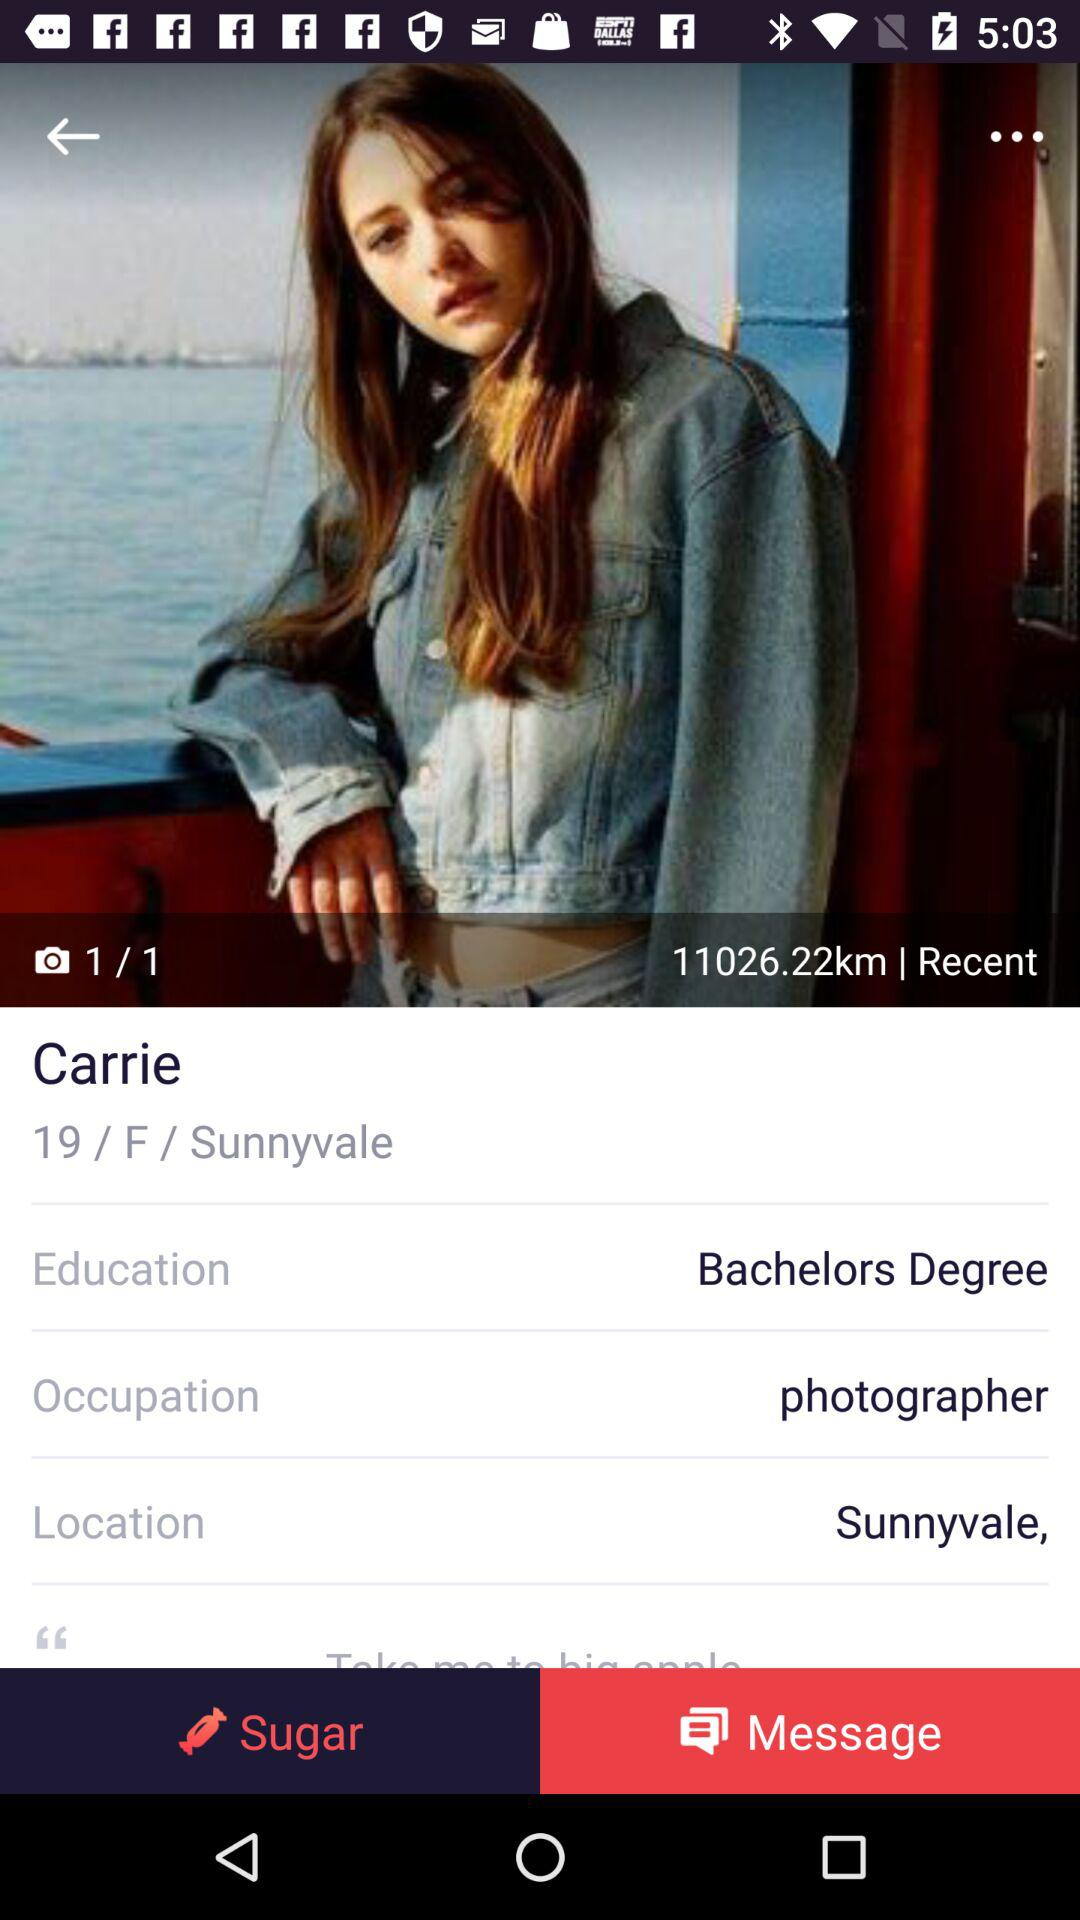What is the selected option?
When the provided information is insufficient, respond with <no answer>. <no answer> 